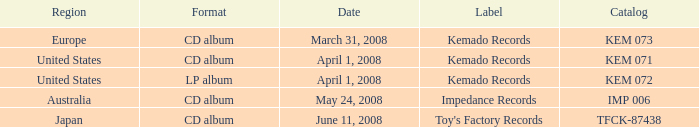Which Format has a Label of toy's factory records? CD album. 